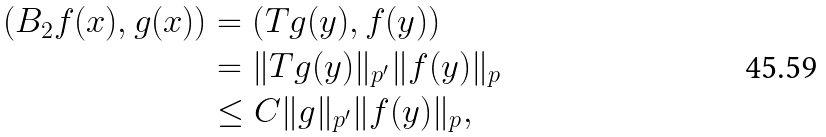<formula> <loc_0><loc_0><loc_500><loc_500>\left ( B _ { 2 } f ( x ) , g ( x ) \right ) & = \left ( T g ( y ) , f ( y ) \right ) \\ & = \| T g ( y ) \| _ { p ^ { \prime } } \| f ( y ) \| _ { p } \\ & \leq C \| g \| _ { p ^ { \prime } } \| f ( y ) \| _ { p } ,</formula> 